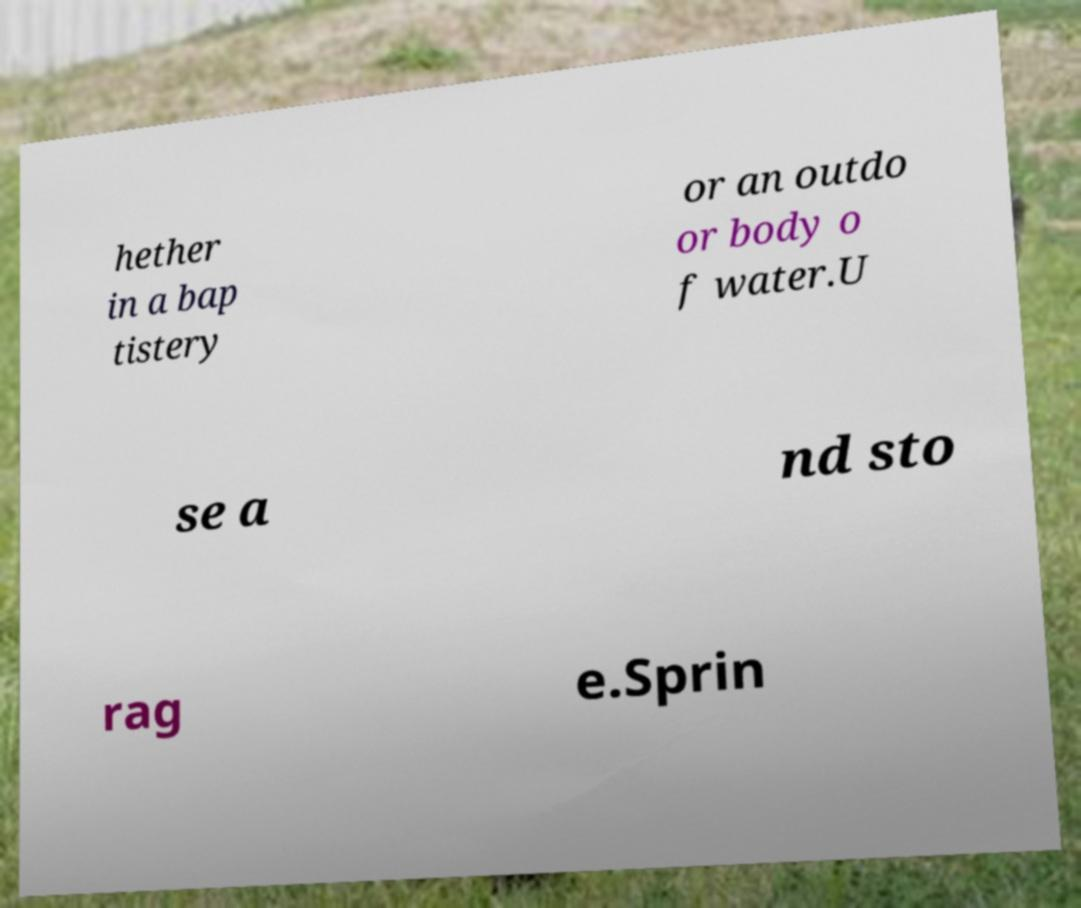Please read and relay the text visible in this image. What does it say? hether in a bap tistery or an outdo or body o f water.U se a nd sto rag e.Sprin 